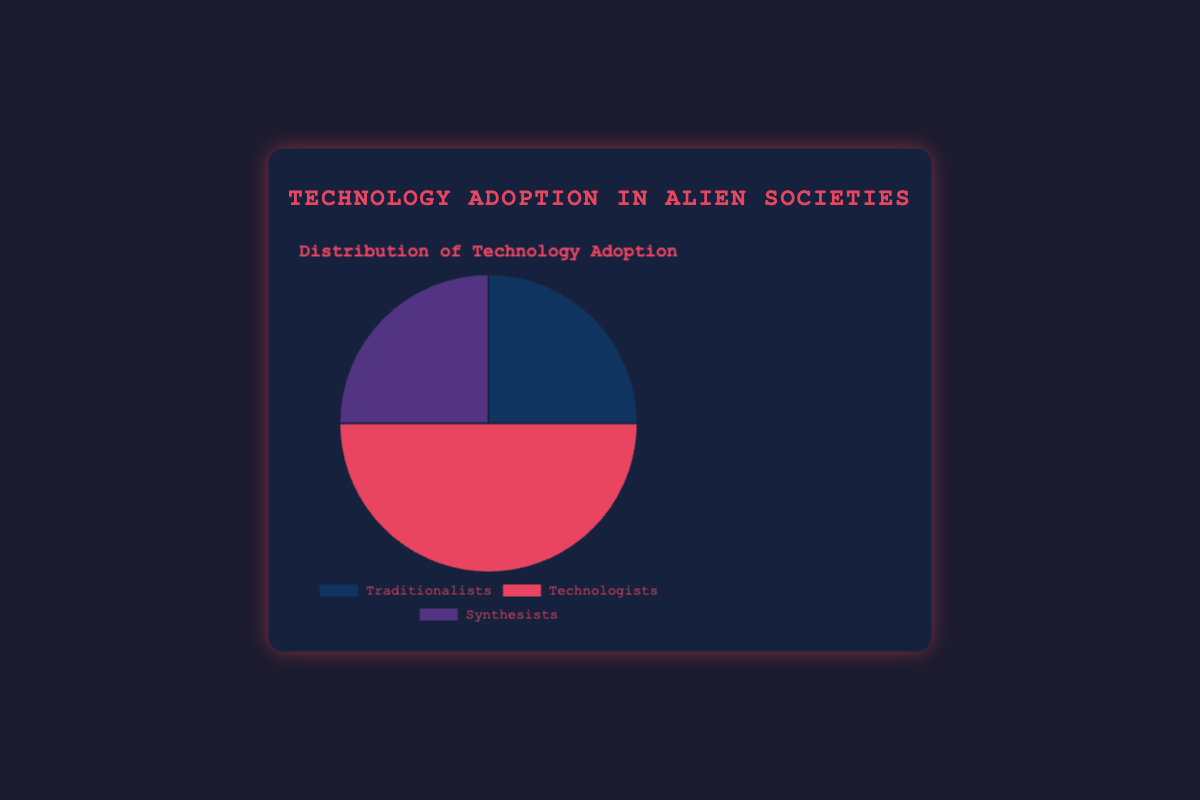What are the names of the three primary alien societies in the chart? The chart labels each section with the names of the societies; they are Traditionalists, Technologists, and Synthesists.
Answer: Traditionalists, Technologists, Synthesists Which society has the lowest and highest technology adoption percentages? Observing the chart, Technologists have the highest percentage at 50%, whereas Traditionalists and Synthesists both have lower percentages at 25%.
Answer: Lowest: Traditionalists, Synthesists; Highest: Technologists Which societies have an equal technology adoption percentage? From the chart, Traditionalists and Synthesists both have the same technology adoption percentage of 25%.
Answer: Traditionalists, Synthesists What is the total percentage of technology adoption by Traditionalists and Synthesists combined? Adding the two percentages from the chart, 25% (Traditionalists) + 25% (Synthesists) = 50%.
Answer: 50% What proportion of the chart does the Technologists' section represent? Technologists' adoption percentage is 50%, meaning they represent half of the pie chart.
Answer: 50% How does the technology adoption of Technologists compare to that of Syntheticists? Comparing 50% (Technologists) to 25% (Synthesists), Technologists' adoption is twice that of Synthesists.
Answer: Twice as much What color represents the Traditionalists in the chart? The section representing Traditionalists is colored blue in the chart.
Answer: Blue If we combined the adoption of technology by Traditionalists and Technologists, what fraction of the total would it be? Adding 25% (Traditionalists) and 50% (Technologists) gives a total of 75%, representing 3/4 of the whole chart.
Answer: 3/4 What is the difference in technology adoption between the highest and lowest adopting societies? The difference between Technologists at 50% and Traditionalists or Synthesists at 25% is 50% - 25% = 25%.
Answer: 25% 